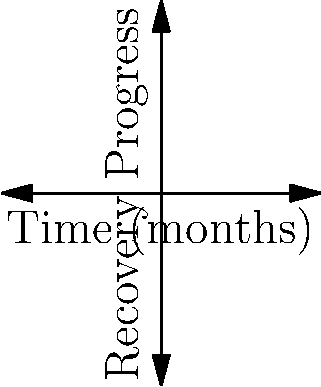The graph shows the mental health recovery progress of a patient over 8 months. Each point represents a stage in the recovery process, with the x-axis showing time in months and the y-axis showing recovery progress on a scale of 1 to 5. What is the total positive change in recovery progress from the beginning to the end of the 8-month period? To find the total positive change in recovery progress, we need to:

1. Identify the initial and final recovery progress values:
   - Initial value (at 0 months): $y_1 = 1$
   - Final value (at 8 months): $y_5 = 5$

2. Calculate the difference between the final and initial values:
   $\text{Total change} = y_5 - y_1 = 5 - 1 = 4$

3. Since we're asked for the positive change, and the result is positive, no further calculation is needed.

Therefore, the total positive change in recovery progress from the beginning to the end of the 8-month period is 4 units on the recovery progress scale.
Answer: 4 